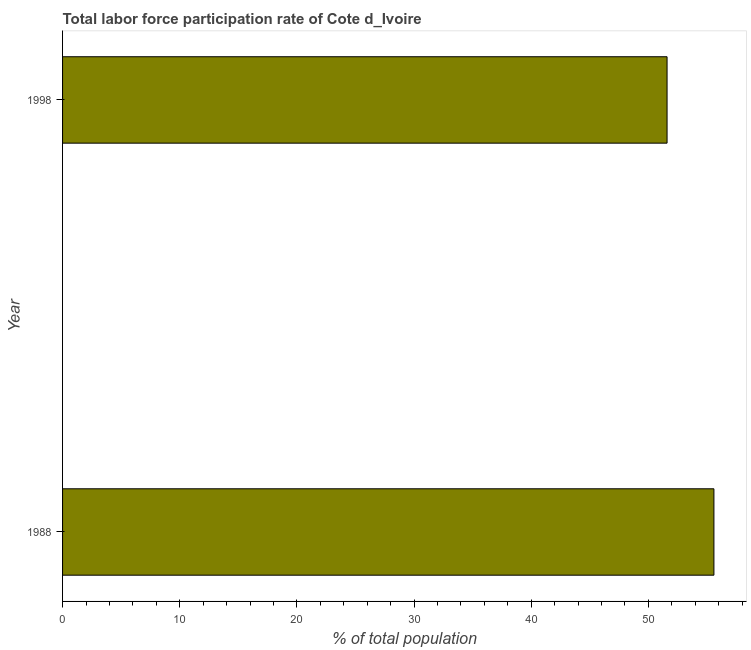What is the title of the graph?
Offer a terse response. Total labor force participation rate of Cote d_Ivoire. What is the label or title of the X-axis?
Make the answer very short. % of total population. What is the total labor force participation rate in 1988?
Your response must be concise. 55.6. Across all years, what is the maximum total labor force participation rate?
Your answer should be very brief. 55.6. Across all years, what is the minimum total labor force participation rate?
Make the answer very short. 51.6. In which year was the total labor force participation rate maximum?
Make the answer very short. 1988. What is the sum of the total labor force participation rate?
Offer a very short reply. 107.2. What is the difference between the total labor force participation rate in 1988 and 1998?
Offer a very short reply. 4. What is the average total labor force participation rate per year?
Provide a short and direct response. 53.6. What is the median total labor force participation rate?
Keep it short and to the point. 53.6. In how many years, is the total labor force participation rate greater than 40 %?
Your answer should be compact. 2. Do a majority of the years between 1998 and 1988 (inclusive) have total labor force participation rate greater than 6 %?
Your response must be concise. No. What is the ratio of the total labor force participation rate in 1988 to that in 1998?
Your answer should be compact. 1.08. Are all the bars in the graph horizontal?
Make the answer very short. Yes. How many years are there in the graph?
Offer a terse response. 2. What is the difference between two consecutive major ticks on the X-axis?
Your answer should be compact. 10. What is the % of total population in 1988?
Provide a succinct answer. 55.6. What is the % of total population of 1998?
Your response must be concise. 51.6. What is the ratio of the % of total population in 1988 to that in 1998?
Your answer should be very brief. 1.08. 